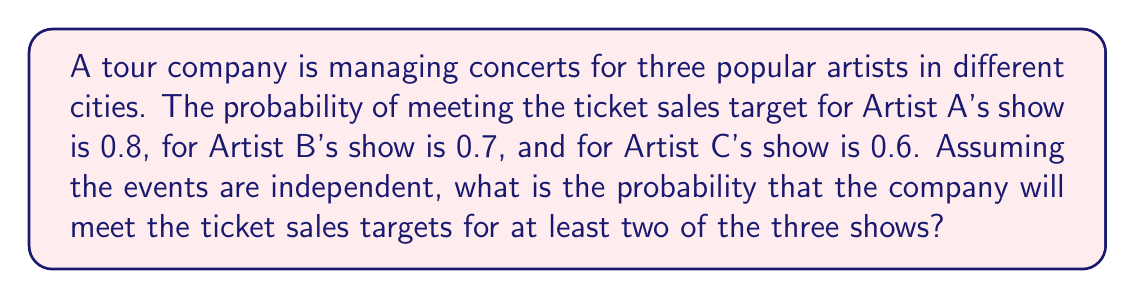Could you help me with this problem? Let's approach this step-by-step:

1) First, we need to calculate the probability of meeting the sales target for at least two shows. This is equivalent to the probability of meeting the target for either two shows or all three shows.

2) Let's use the complement method. It's easier to calculate the probability of not meeting the target for at least two shows and then subtract this from 1.

3) The probability of not meeting the target for at least two shows is the sum of the probabilities of:
   a) Meeting the target for no shows
   b) Meeting the target for exactly one show

4) Probability of meeting the target for no shows:
   $$(1-0.8) \times (1-0.7) \times (1-0.6) = 0.2 \times 0.3 \times 0.4 = 0.024$$

5) Probability of meeting the target for exactly one show:
   a) Only A: $$0.8 \times (1-0.7) \times (1-0.6) = 0.8 \times 0.3 \times 0.4 = 0.096$$
   b) Only B: $$(1-0.8) \times 0.7 \times (1-0.6) = 0.2 \times 0.7 \times 0.4 = 0.056$$
   c) Only C: $$(1-0.8) \times (1-0.7) \times 0.6 = 0.2 \times 0.3 \times 0.6 = 0.036$$

6) Sum of probabilities for meeting the target for exactly one show:
   $$0.096 + 0.056 + 0.036 = 0.188$$

7) Total probability of not meeting the target for at least two shows:
   $$0.024 + 0.188 = 0.212$$

8) Therefore, the probability of meeting the target for at least two shows is:
   $$1 - 0.212 = 0.788$$
Answer: 0.788 